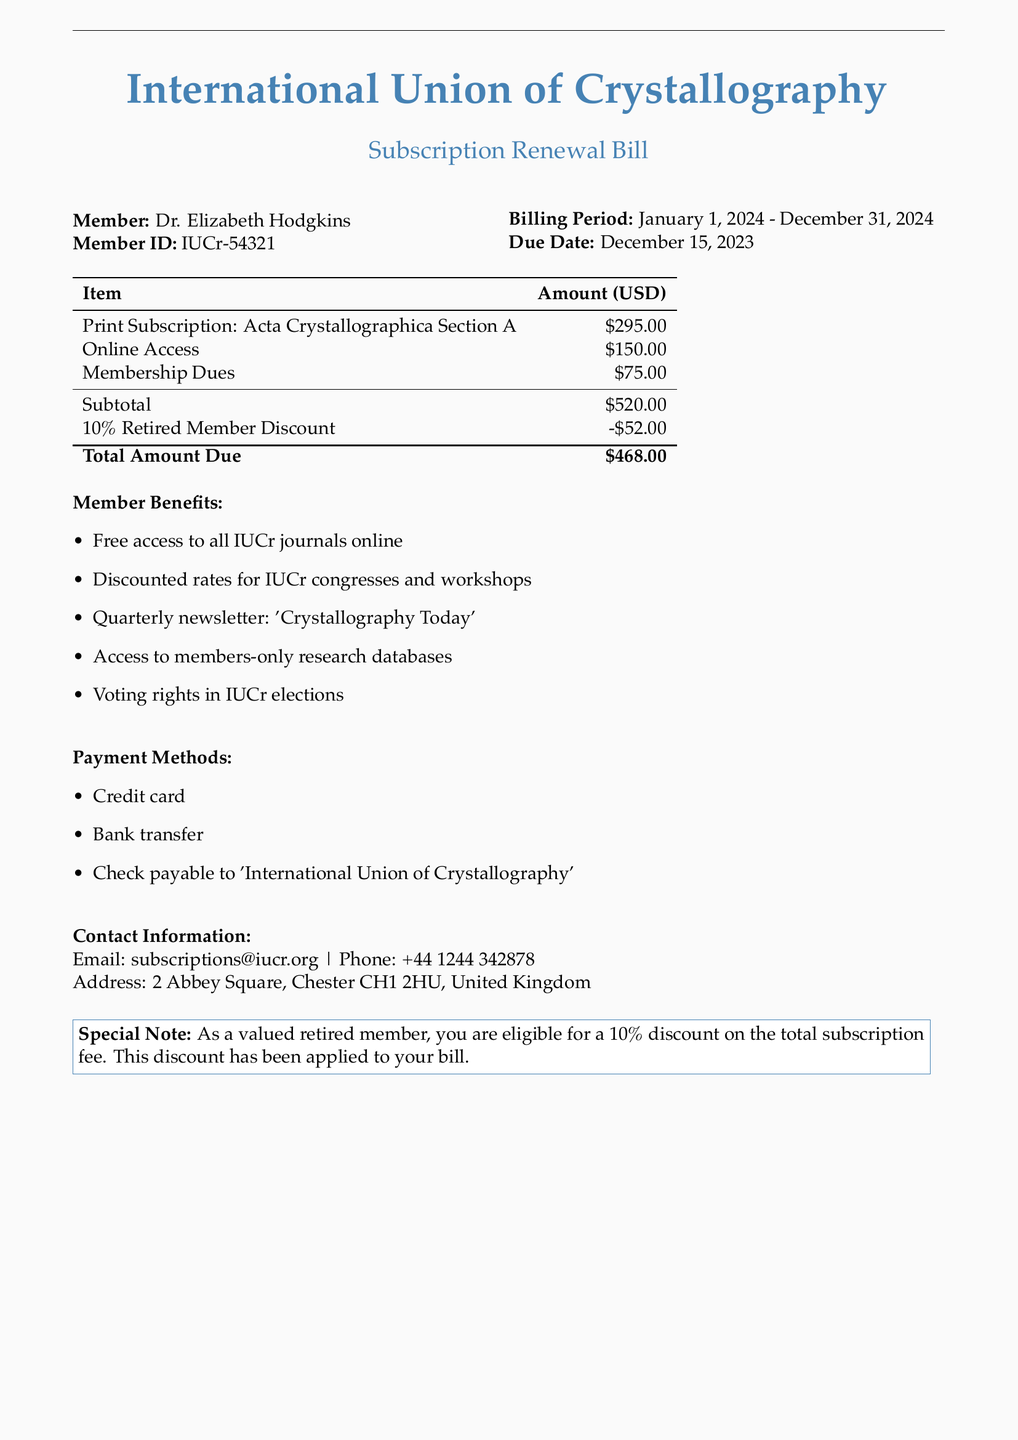What is the member ID of Dr. Elizabeth Hodgkins? The member ID is specified in the document under the member details.
Answer: IUCr-54321 What is the total amount due? The total amount due is calculated in the billing table at the bottom of the document.
Answer: $468.00 What is the billing period for this subscription? The billing period is mentioned clearly in the member details section of the document.
Answer: January 1, 2024 - December 31, 2024 What discount is applied for retired members? The document states the specific percentage discount applicable to retired members.
Answer: 10% What are the payment methods listed? The document provides a list of acceptable payment methods clearly laid out in the payment section.
Answer: Credit card, Bank transfer, Check How much is the print subscription for Acta Crystallographica Section A? The amount for the print subscription is given in the breakdown of annual fees.
Answer: $295.00 What is the email contact for subscriptions? The contact information section includes the email address for subscriptions inquiries.
Answer: subscriptions@iucr.org What is one benefit of being a member? The document lists various member benefits, one of which can be identified easily.
Answer: Free access to all IUCr journals online What is the due date for renewal payment? The due date is specifically stated in the member details portion of the document.
Answer: December 15, 2023 